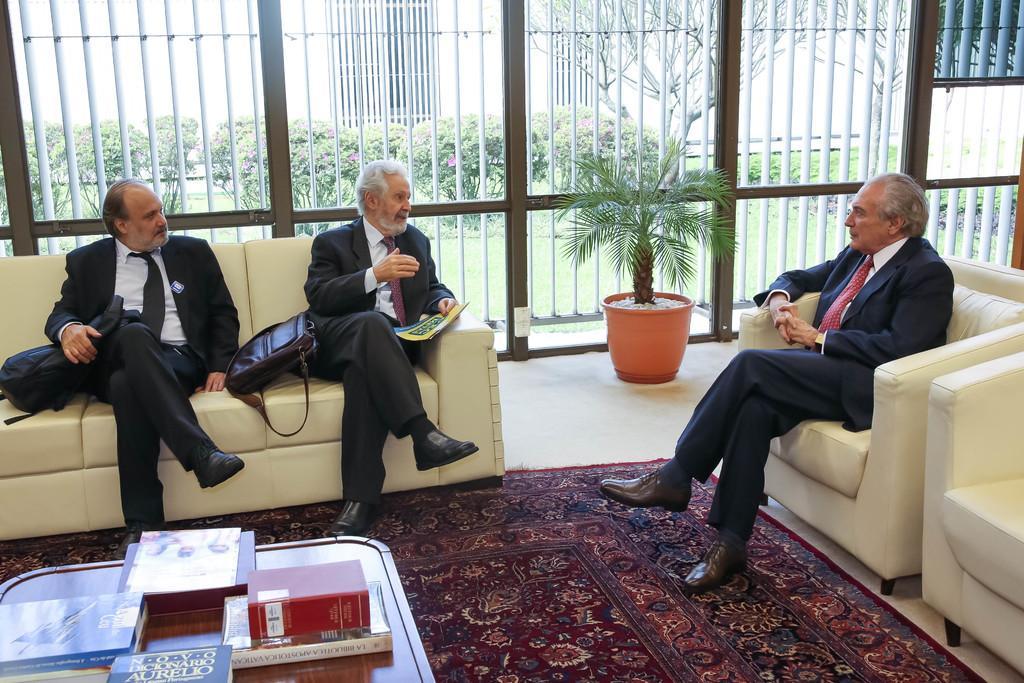Could you give a brief overview of what you see in this image? In this image, in the left side there is a black color table, on that table there are some books and there is a red color object kept on the table, there are sofas which are in white color and there are some people sitting on the sofas, in the background there is a green color plant and there is a black color fence. 